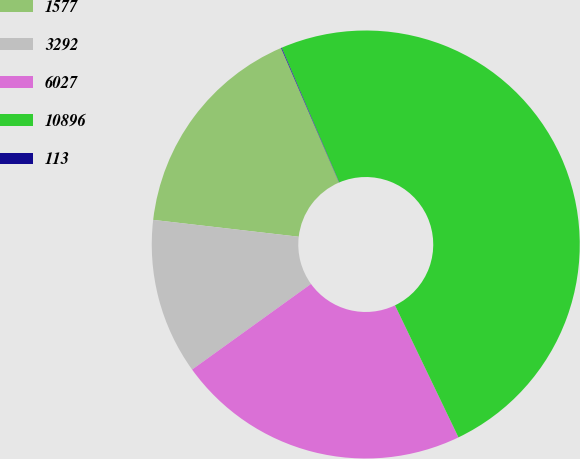Convert chart. <chart><loc_0><loc_0><loc_500><loc_500><pie_chart><fcel>1577<fcel>3292<fcel>6027<fcel>10896<fcel>113<nl><fcel>16.69%<fcel>11.77%<fcel>22.2%<fcel>49.3%<fcel>0.05%<nl></chart> 